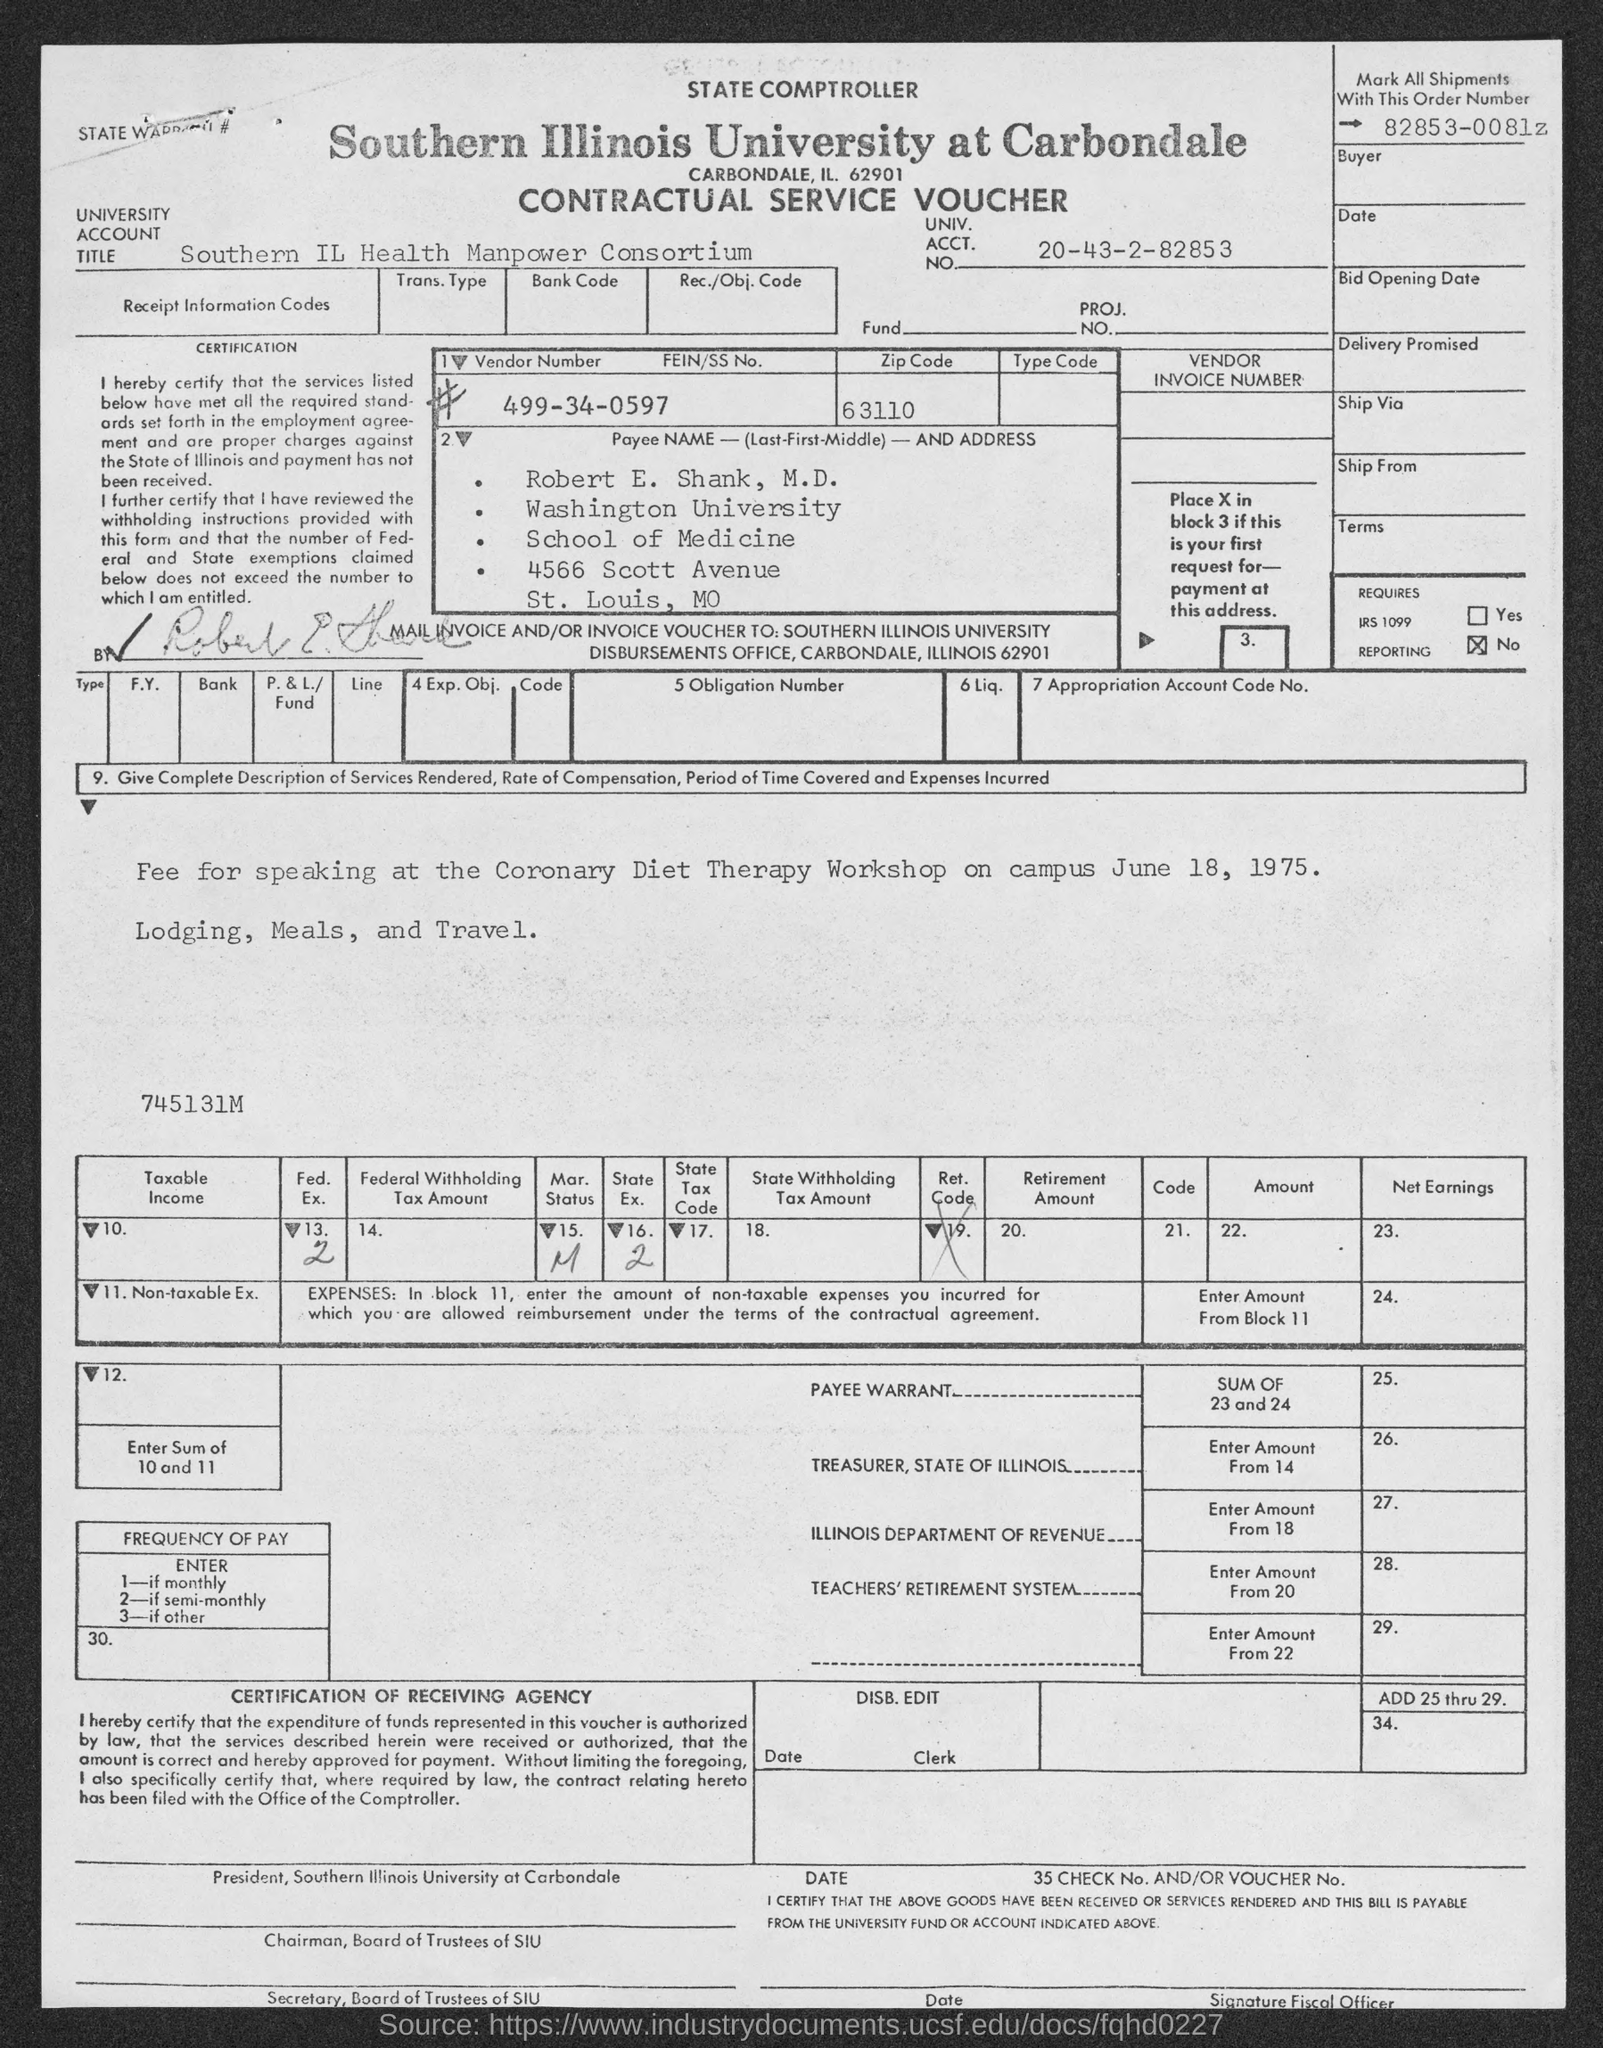Identify some key points in this picture. The order number used to mark all shipments is 82853-0081z. This voucher is a contractual service voucher. The payee name listed on the voucher is Robert E. Shank, M.D. The zip code listed on the voucher is 63110. The given vendor number in the voucher is 499-34-0597. 